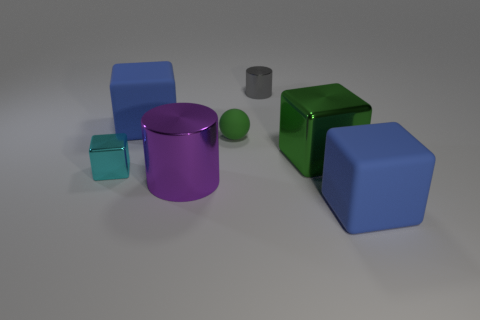The large object that is right of the purple metal object and in front of the green block is what color?
Ensure brevity in your answer.  Blue. How big is the blue rubber object that is to the right of the big blue rubber object that is behind the purple metal cylinder that is in front of the large green block?
Give a very brief answer. Large. What number of objects are large blue objects behind the small cyan shiny block or blue matte things that are on the left side of the large green object?
Ensure brevity in your answer.  1. The small gray metallic thing has what shape?
Ensure brevity in your answer.  Cylinder. How many other objects are the same material as the green sphere?
Ensure brevity in your answer.  2. What size is the purple metallic object that is the same shape as the gray thing?
Give a very brief answer. Large. What material is the small cylinder that is left of the blue thing that is in front of the blue block on the left side of the ball made of?
Offer a terse response. Metal. Are there any tiny red cylinders?
Offer a very short reply. No. Does the tiny cylinder have the same color as the big metal thing that is on the left side of the big green cube?
Ensure brevity in your answer.  No. The tiny ball has what color?
Your answer should be compact. Green. 